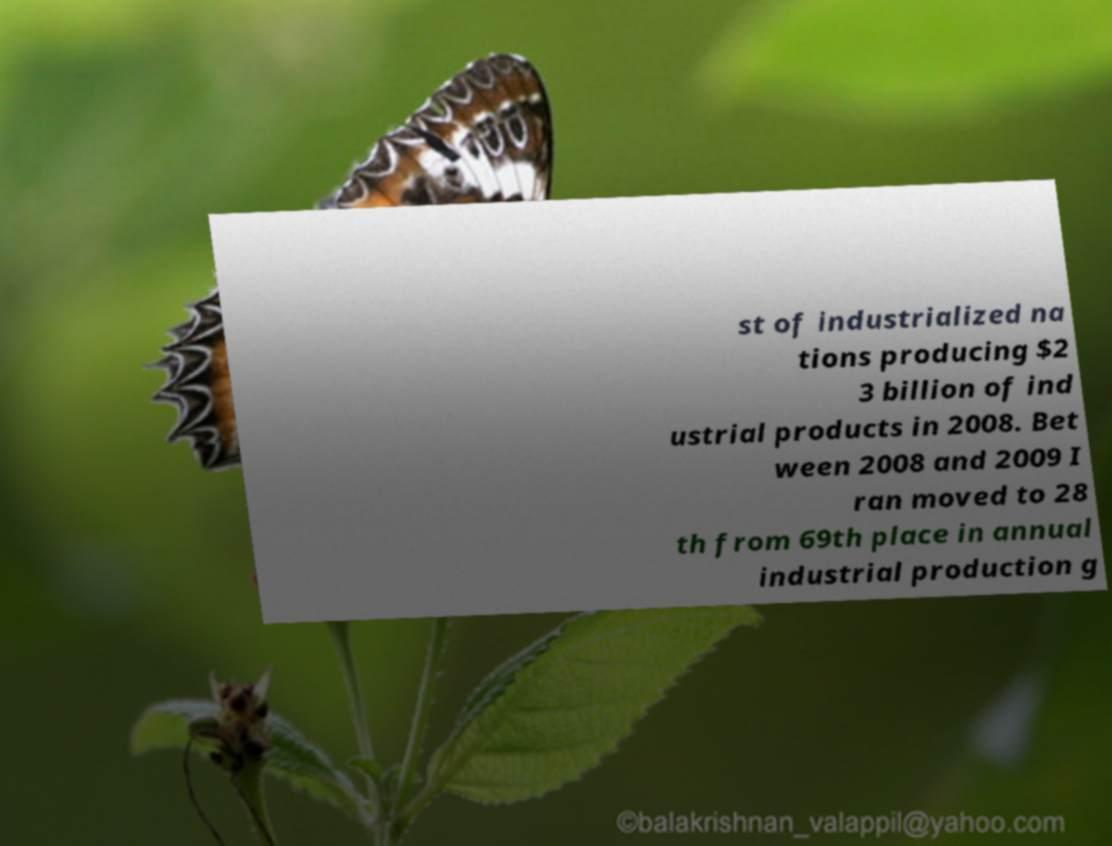Can you read and provide the text displayed in the image?This photo seems to have some interesting text. Can you extract and type it out for me? st of industrialized na tions producing $2 3 billion of ind ustrial products in 2008. Bet ween 2008 and 2009 I ran moved to 28 th from 69th place in annual industrial production g 